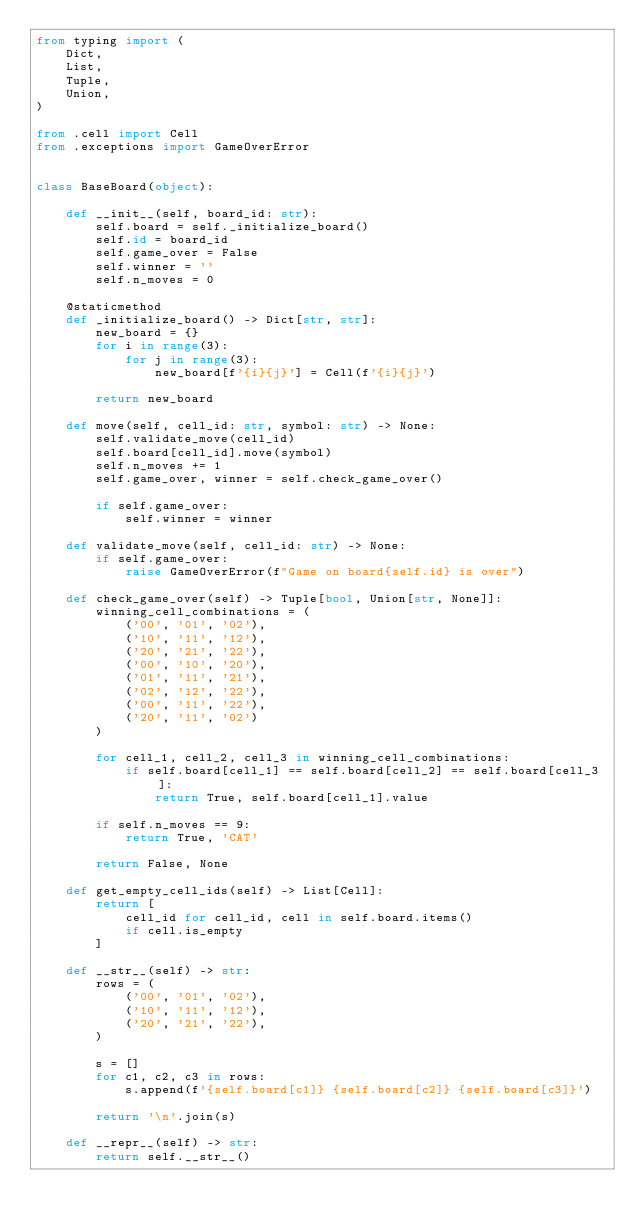<code> <loc_0><loc_0><loc_500><loc_500><_Python_>from typing import (
    Dict,
    List,
    Tuple,
    Union,
)

from .cell import Cell
from .exceptions import GameOverError


class BaseBoard(object):
    
    def __init__(self, board_id: str):
        self.board = self._initialize_board()
        self.id = board_id
        self.game_over = False
        self.winner = ''
        self.n_moves = 0
        
    @staticmethod
    def _initialize_board() -> Dict[str, str]:
        new_board = {}
        for i in range(3):
            for j in range(3):
                new_board[f'{i}{j}'] = Cell(f'{i}{j}')
                
        return new_board
    
    def move(self, cell_id: str, symbol: str) -> None:
        self.validate_move(cell_id)
        self.board[cell_id].move(symbol)
        self.n_moves += 1
        self.game_over, winner = self.check_game_over()   
        
        if self.game_over:
            self.winner = winner
        
    def validate_move(self, cell_id: str) -> None:
        if self.game_over:
            raise GameOverError(f"Game on board{self.id} is over")
    
    def check_game_over(self) -> Tuple[bool, Union[str, None]]:
        winning_cell_combinations = (
            ('00', '01', '02'),
            ('10', '11', '12'),
            ('20', '21', '22'),
            ('00', '10', '20'),
            ('01', '11', '21'),
            ('02', '12', '22'),
            ('00', '11', '22'),
            ('20', '11', '02')
        )
        
        for cell_1, cell_2, cell_3 in winning_cell_combinations:
            if self.board[cell_1] == self.board[cell_2] == self.board[cell_3]:
                return True, self.board[cell_1].value
        
        if self.n_moves == 9:
            return True, 'CAT'
        
        return False, None
    
    def get_empty_cell_ids(self) -> List[Cell]:
        return [
            cell_id for cell_id, cell in self.board.items()
            if cell.is_empty
        ]
        
    def __str__(self) -> str:
        rows = (
            ('00', '01', '02'),
            ('10', '11', '12'),
            ('20', '21', '22'),
        )
        
        s = []
        for c1, c2, c3 in rows:
            s.append(f'{self.board[c1]} {self.board[c2]} {self.board[c3]}')
            
        return '\n'.join(s)
    
    def __repr__(self) -> str:
        return self.__str__()
    </code> 